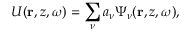<formula> <loc_0><loc_0><loc_500><loc_500>U ( { r } , z , \omega ) = \sum _ { \nu } a _ { \nu } \Psi _ { \nu } ( { r } , z , \omega ) ,</formula> 